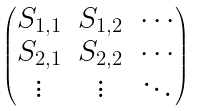Convert formula to latex. <formula><loc_0><loc_0><loc_500><loc_500>\begin{pmatrix} S _ { 1 , 1 } & S _ { 1 , 2 } & \cdots \\ S _ { 2 , 1 } & S _ { 2 , 2 } & \cdots \\ \vdots & \vdots & \ddots \end{pmatrix}</formula> 